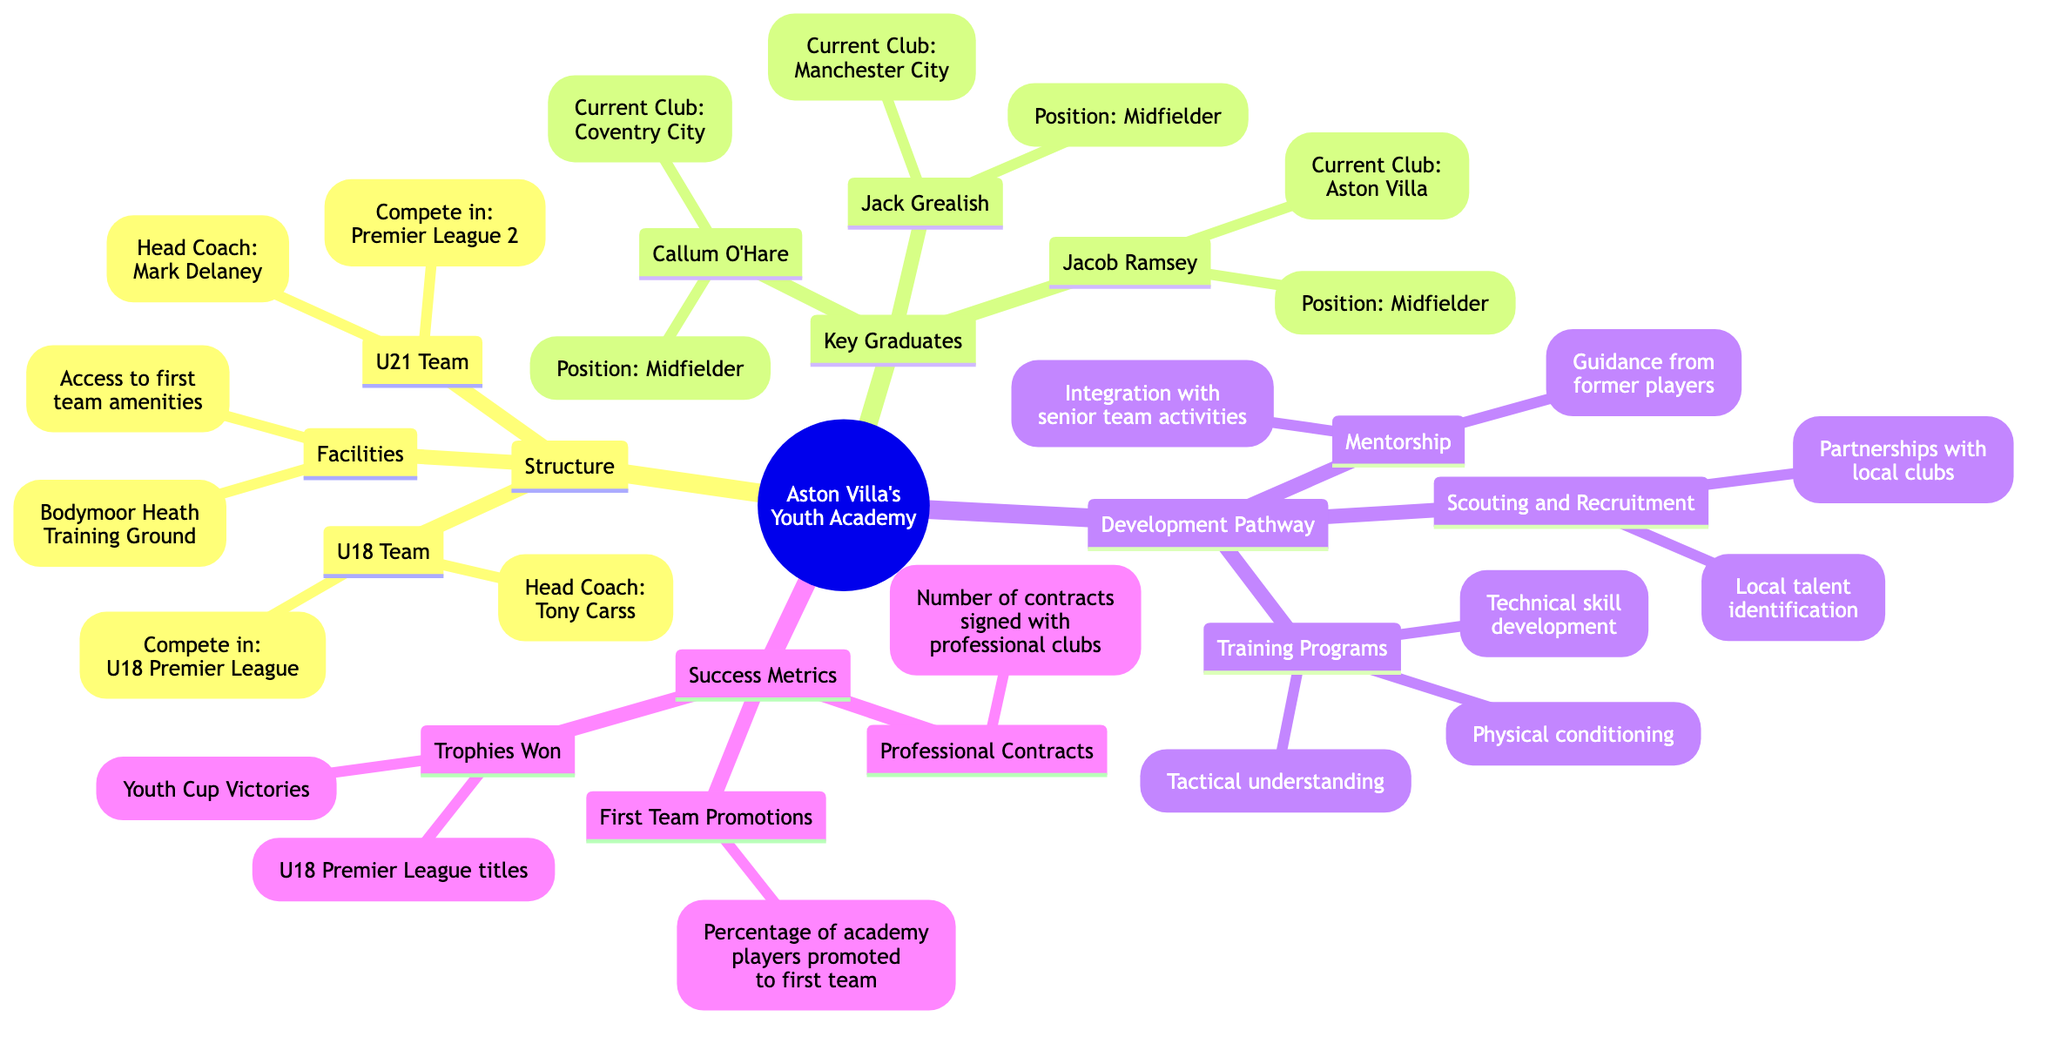What are the names of the U21 Team coaches? The U21 Team has a head coach named Mark Delaney. This information is directly connected under the "U21 Team" node in the diagram. Therefore, the answer is Mark Delaney.
Answer: Mark Delaney How many key graduates are listed in the diagram? The diagram lists three key graduates: Jack Grealish, Jacob Ramsey, and Callum O'Hare. By counting the nodes under "Key Graduates," we find the total number of graduates.
Answer: 3 What does the U18 Team compete in? The U18 Team competes in the U18 Premier League. This specific competition is mentioned under the "U18 Team" node in the diagram.
Answer: U18 Premier League Which facility is associated with Aston Villa's Youth Academy? The Bodymoor Heath Training Ground is the facility associated with the academy mentioned under the "Facilities" node. This is a specific entity directly stated in the diagram.
Answer: Bodymoor Heath Training Ground What percentage of academy players are promoted to the first team? The diagram notes that a specific percentage of academy players is promoted to the first team but does not specify the exact number, representing a success metric under "First Team Promotions." Since the prompt asks about the category, the answer focuses on that aspect.
Answer: Percentage of academy players promoted to first team What types of training does the Development Pathway focus on? The Development Pathway includes training programs on technical skill development, tactical understanding, and physical conditioning which are listed under "Training Programs." These three aspects combine to form a comprehensive view of the training focus at the academy.
Answer: Technical skill development, Tactical understanding, Physical conditioning Who is the current club for Jacob Ramsey? Jacob Ramsey's current club is Aston Villa. This information is associated with his name under the "Key Graduates" section in the diagram.
Answer: Aston Villa What is one of the success metrics listed in the academy structure? One of the success metrics mentioned is the number of contracts signed with professional clubs, which falls under "Professional Contracts." This provides insight into the outcomes of the academy's efforts.
Answer: Number of contracts signed with professional clubs What form of guidance is available to academy players? The academy players receive mentorship, specifically described as guidance from former players as noted in the "Mentorship" section of the "Development Pathway." This indicates a support structure in place for player development.
Answer: Guidance from former players Which team in Aston Villa's Youth Academy has the head coach Tony Carss? The U18 Team has Tony Carss as its head coach. This specific relationship is depicted under the "U18 Team" node.
Answer: U18 Team 